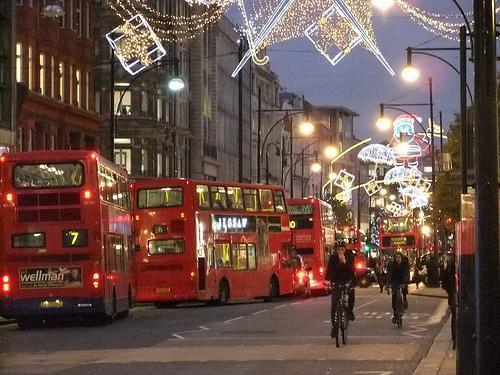How many buses?
Give a very brief answer. 4. How many people riding bikes?
Give a very brief answer. 2. 